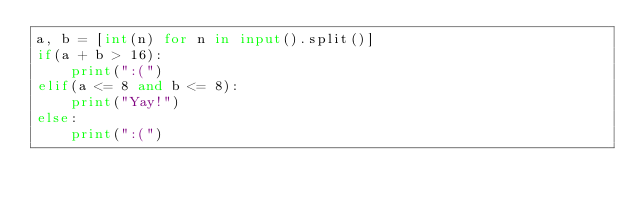Convert code to text. <code><loc_0><loc_0><loc_500><loc_500><_Python_>a, b = [int(n) for n in input().split()]
if(a + b > 16):
    print(":(")
elif(a <= 8 and b <= 8):
    print("Yay!")
else:
    print(":(")</code> 